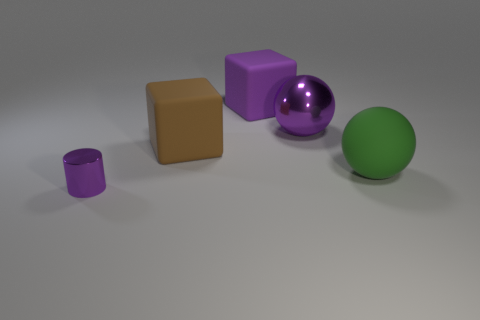Add 4 purple shiny cylinders. How many objects exist? 9 Subtract all blocks. How many objects are left? 3 Add 3 large purple metallic things. How many large purple metallic things are left? 4 Add 1 big green rubber balls. How many big green rubber balls exist? 2 Subtract 0 blue cubes. How many objects are left? 5 Subtract all rubber cylinders. Subtract all small cylinders. How many objects are left? 4 